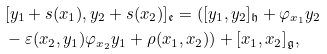<formula> <loc_0><loc_0><loc_500><loc_500>& [ y _ { 1 } + s ( x _ { 1 } ) , y _ { 2 } + s ( x _ { 2 } ) ] _ { \mathfrak { e } } = ( [ y _ { 1 } , y _ { 2 } ] _ { \mathfrak { h } } + \varphi _ { x _ { 1 } } y _ { 2 } \\ & - \varepsilon ( x _ { 2 } , y _ { 1 } ) \varphi _ { x _ { 2 } } y _ { 1 } + \rho ( x _ { 1 } , x _ { 2 } ) ) + [ x _ { 1 } , x _ { 2 } ] _ { \mathfrak { g } } ,</formula> 